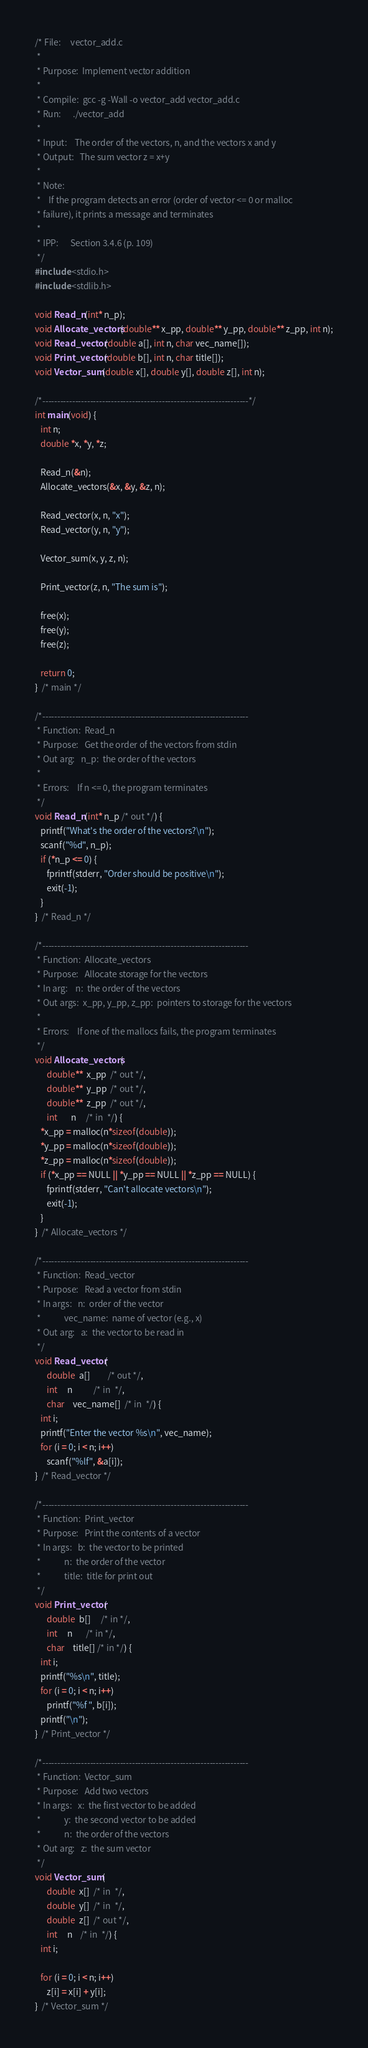Convert code to text. <code><loc_0><loc_0><loc_500><loc_500><_C_>/* File:     vector_add.c
 *
 * Purpose:  Implement vector addition
 *
 * Compile:  gcc -g -Wall -o vector_add vector_add.c
 * Run:      ./vector_add
 *
 * Input:    The order of the vectors, n, and the vectors x and y
 * Output:   The sum vector z = x+y
 *
 * Note:
 *    If the program detects an error (order of vector <= 0 or malloc
 * failure), it prints a message and terminates
 *
 * IPP:      Section 3.4.6 (p. 109)
 */
#include <stdio.h>
#include <stdlib.h>

void Read_n(int* n_p);
void Allocate_vectors(double** x_pp, double** y_pp, double** z_pp, int n);
void Read_vector(double a[], int n, char vec_name[]);
void Print_vector(double b[], int n, char title[]);
void Vector_sum(double x[], double y[], double z[], int n);

/*---------------------------------------------------------------------*/
int main(void) {
   int n;
   double *x, *y, *z;

   Read_n(&n);
   Allocate_vectors(&x, &y, &z, n);
   
   Read_vector(x, n, "x");
   Read_vector(y, n, "y");
   
   Vector_sum(x, y, z, n);

   Print_vector(z, n, "The sum is");

   free(x);
   free(y);
   free(z);

   return 0;
}  /* main */

/*---------------------------------------------------------------------
 * Function:  Read_n
 * Purpose:   Get the order of the vectors from stdin
 * Out arg:   n_p:  the order of the vectors
 *
 * Errors:    If n <= 0, the program terminates
 */
void Read_n(int* n_p /* out */) {
   printf("What's the order of the vectors?\n");
   scanf("%d", n_p);
   if (*n_p <= 0) {
      fprintf(stderr, "Order should be positive\n");
      exit(-1);
   }
}  /* Read_n */

/*---------------------------------------------------------------------
 * Function:  Allocate_vectors
 * Purpose:   Allocate storage for the vectors
 * In arg:    n:  the order of the vectors
 * Out args:  x_pp, y_pp, z_pp:  pointers to storage for the vectors
 *
 * Errors:    If one of the mallocs fails, the program terminates
 */
void Allocate_vectors(
      double**  x_pp  /* out */, 
      double**  y_pp  /* out */, 
      double**  z_pp  /* out */, 
      int       n     /* in  */) {
   *x_pp = malloc(n*sizeof(double));
   *y_pp = malloc(n*sizeof(double));
   *z_pp = malloc(n*sizeof(double));
   if (*x_pp == NULL || *y_pp == NULL || *z_pp == NULL) {
      fprintf(stderr, "Can't allocate vectors\n");
      exit(-1);
   }
}  /* Allocate_vectors */

/*---------------------------------------------------------------------
 * Function:  Read_vector
 * Purpose:   Read a vector from stdin
 * In args:   n:  order of the vector
 *            vec_name:  name of vector (e.g., x)
 * Out arg:   a:  the vector to be read in
 */
void Read_vector(
      double  a[]         /* out */, 
      int     n           /* in  */, 
      char    vec_name[]  /* in  */) {
   int i;
   printf("Enter the vector %s\n", vec_name);
   for (i = 0; i < n; i++)
      scanf("%lf", &a[i]);
}  /* Read_vector */  

/*---------------------------------------------------------------------
 * Function:  Print_vector
 * Purpose:   Print the contents of a vector
 * In args:   b:  the vector to be printed
 *            n:  the order of the vector
 *            title:  title for print out
 */
void Print_vector(
      double  b[]     /* in */, 
      int     n       /* in */, 
      char    title[] /* in */) {
   int i;
   printf("%s\n", title);
   for (i = 0; i < n; i++)
      printf("%f ", b[i]);
   printf("\n");
}  /* Print_vector */

/*---------------------------------------------------------------------
 * Function:  Vector_sum
 * Purpose:   Add two vectors
 * In args:   x:  the first vector to be added
 *            y:  the second vector to be added
 *            n:  the order of the vectors
 * Out arg:   z:  the sum vector
 */
void Vector_sum(
      double  x[]  /* in  */, 
      double  y[]  /* in  */, 
      double  z[]  /* out */, 
      int     n    /* in  */) {
   int i;

   for (i = 0; i < n; i++)
      z[i] = x[i] + y[i];
}  /* Vector_sum */
</code> 